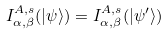Convert formula to latex. <formula><loc_0><loc_0><loc_500><loc_500>I _ { \alpha , \beta } ^ { A , s } ( | \psi \rangle ) = I _ { \alpha , \beta } ^ { A , s } ( | \psi ^ { \prime } \rangle )</formula> 